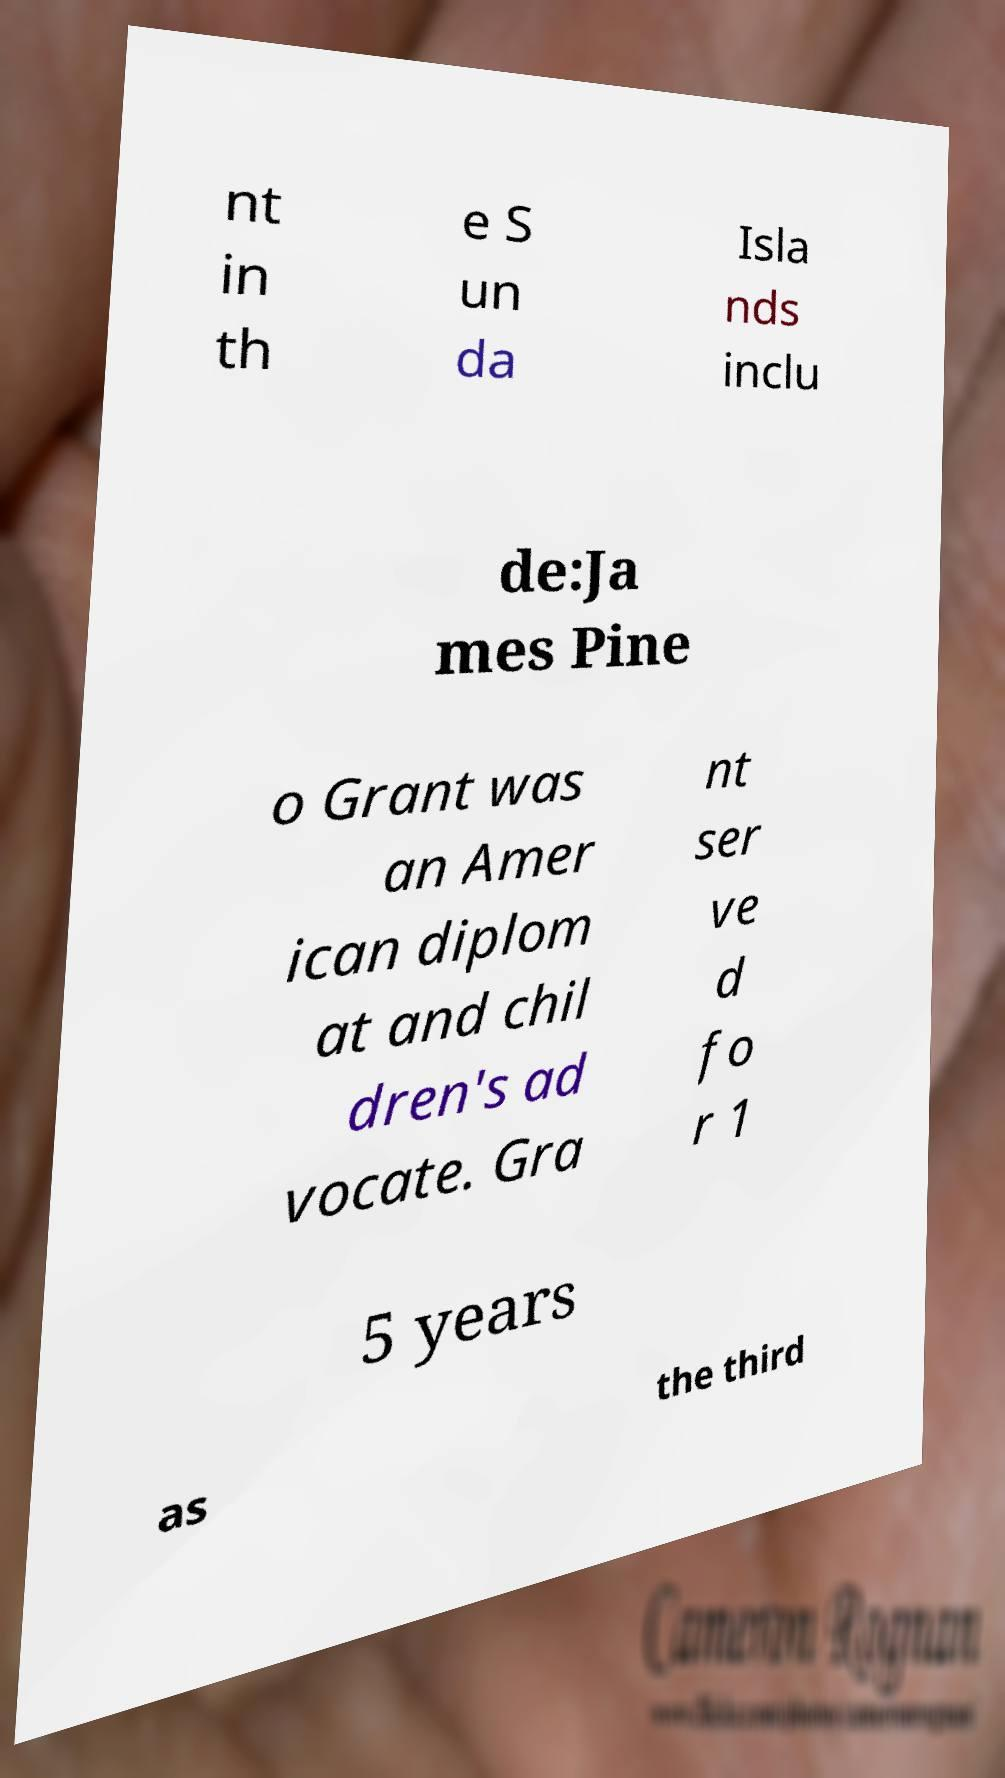Can you read and provide the text displayed in the image?This photo seems to have some interesting text. Can you extract and type it out for me? nt in th e S un da Isla nds inclu de:Ja mes Pine o Grant was an Amer ican diplom at and chil dren's ad vocate. Gra nt ser ve d fo r 1 5 years as the third 